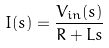<formula> <loc_0><loc_0><loc_500><loc_500>I ( s ) = \frac { V _ { i n } ( s ) } { R + L s }</formula> 